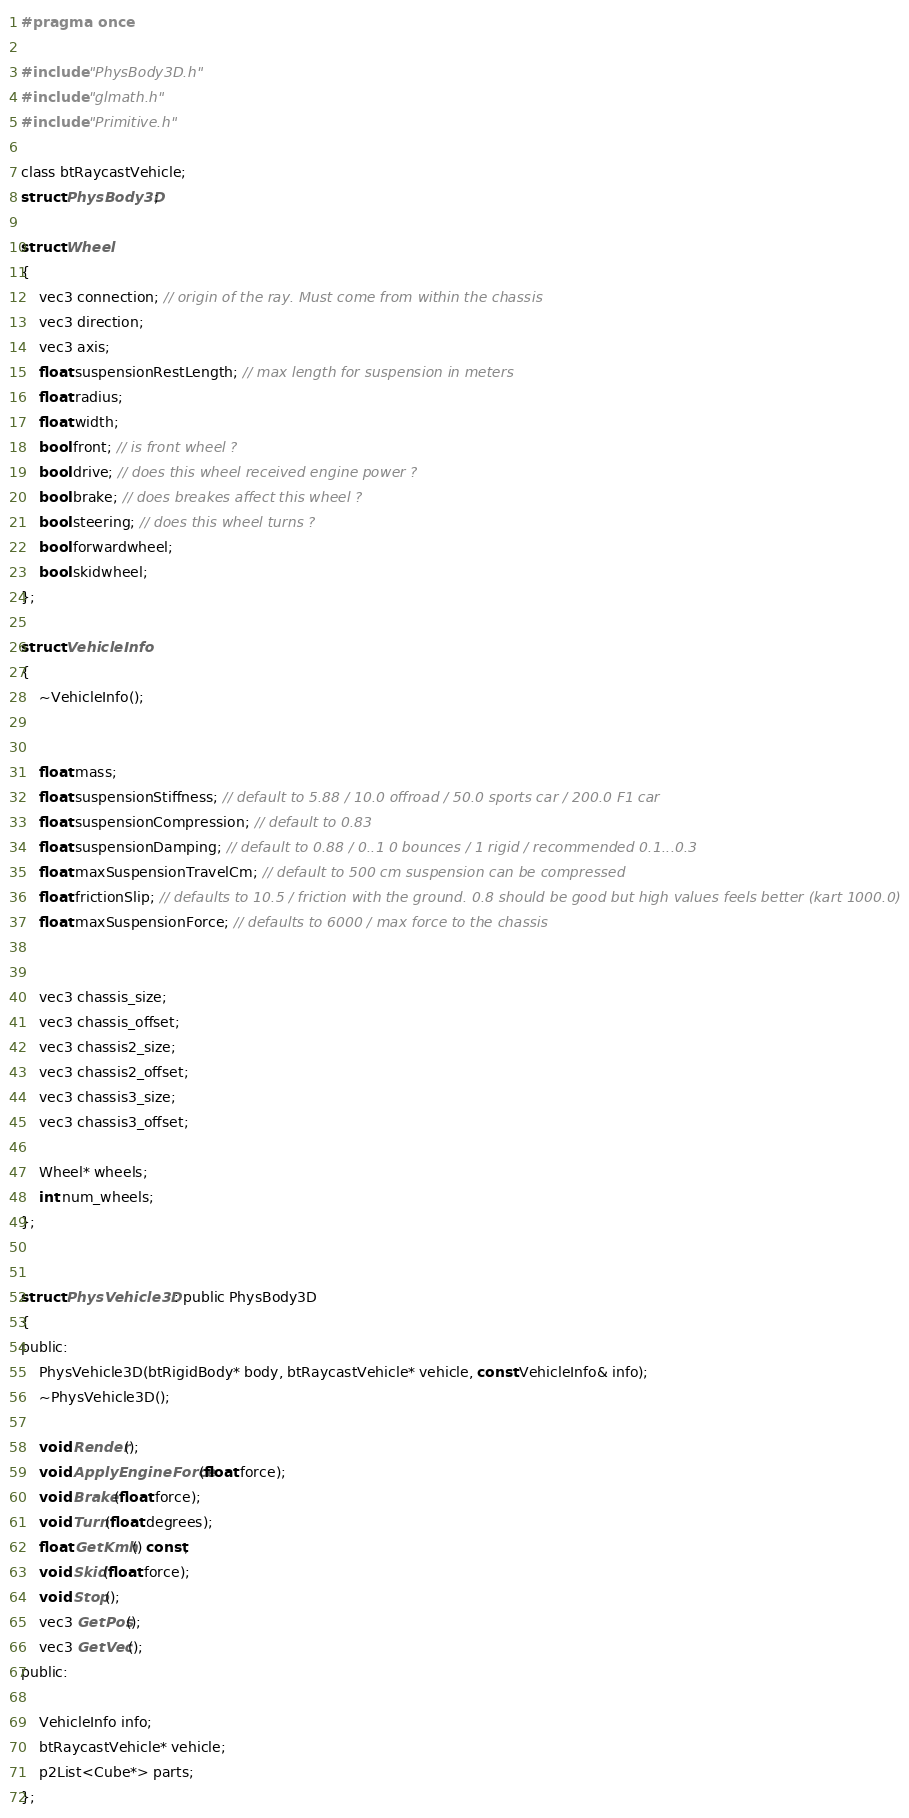Convert code to text. <code><loc_0><loc_0><loc_500><loc_500><_C_>#pragma once

#include "PhysBody3D.h"
#include "glmath.h"
#include "Primitive.h"

class btRaycastVehicle;
struct PhysBody3D;

struct Wheel
{
	vec3 connection; // origin of the ray. Must come from within the chassis
	vec3 direction; 
	vec3 axis;
	float suspensionRestLength; // max length for suspension in meters
	float radius;
	float width;
	bool front; // is front wheel ?
	bool drive; // does this wheel received engine power ?
	bool brake; // does breakes affect this wheel ?
	bool steering; // does this wheel turns ?
	bool forwardwheel;
	bool skidwheel;
};

struct VehicleInfo
{
	~VehicleInfo();
	
	
	float mass;
	float suspensionStiffness; // default to 5.88 / 10.0 offroad / 50.0 sports car / 200.0 F1 car
	float suspensionCompression; // default to 0.83
	float suspensionDamping; // default to 0.88 / 0..1 0 bounces / 1 rigid / recommended 0.1...0.3
	float maxSuspensionTravelCm; // default to 500 cm suspension can be compressed
	float frictionSlip; // defaults to 10.5 / friction with the ground. 0.8 should be good but high values feels better (kart 1000.0)
	float maxSuspensionForce; // defaults to 6000 / max force to the chassis
    
	
	vec3 chassis_size;
	vec3 chassis_offset;
    vec3 chassis2_size;
	vec3 chassis2_offset;
	vec3 chassis3_size;
	vec3 chassis3_offset;

	Wheel* wheels;
	int num_wheels;
};


struct PhysVehicle3D : public PhysBody3D
{
public:
	PhysVehicle3D(btRigidBody* body, btRaycastVehicle* vehicle, const VehicleInfo& info);
	~PhysVehicle3D();

	void Render();
	void ApplyEngineForce(float force);
	void Brake(float force);
	void Turn(float degrees);
	float GetKmh() const;
	void Skid(float force);
	void Stop();
	vec3 GetPos();
	vec3 GetVec();
public:

	VehicleInfo info;
	btRaycastVehicle* vehicle;
	p2List<Cube*> parts;
};</code> 